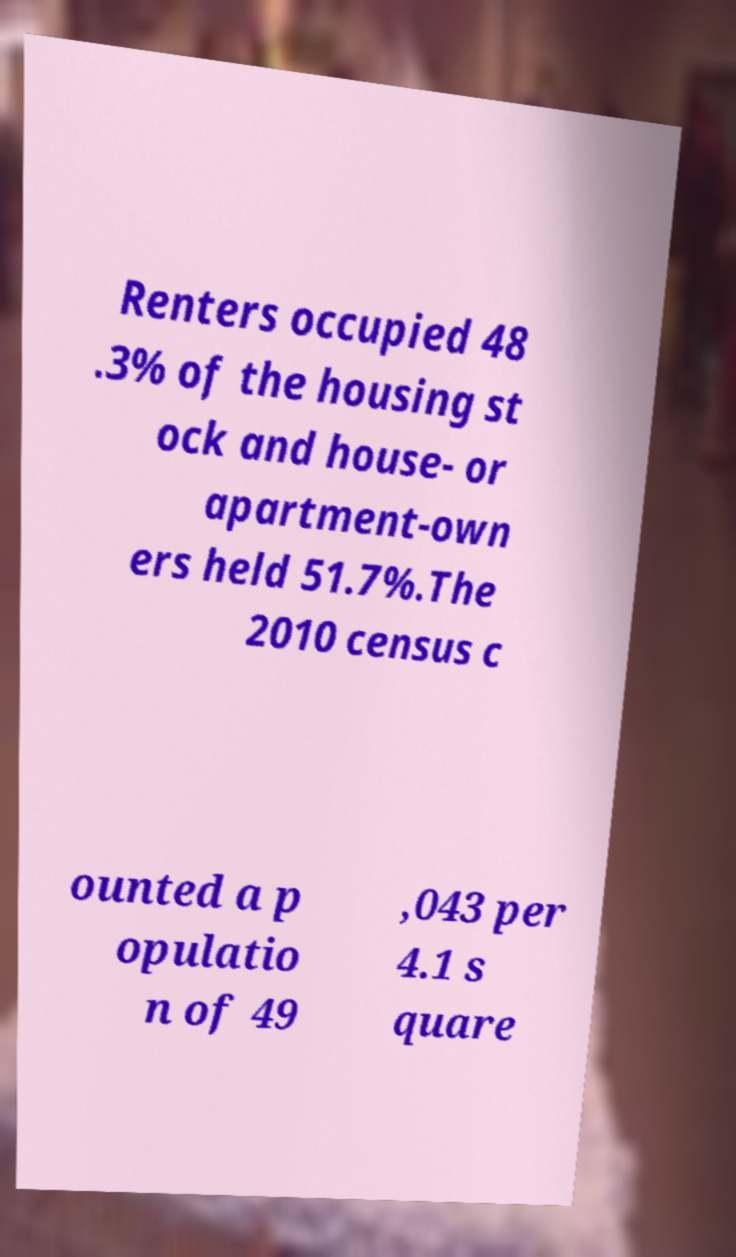There's text embedded in this image that I need extracted. Can you transcribe it verbatim? Renters occupied 48 .3% of the housing st ock and house- or apartment-own ers held 51.7%.The 2010 census c ounted a p opulatio n of 49 ,043 per 4.1 s quare 